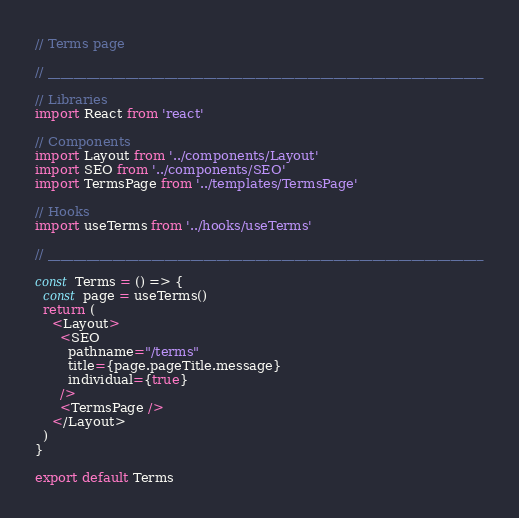<code> <loc_0><loc_0><loc_500><loc_500><_TypeScript_>// Terms page

// ___________________________________________________________________

// Libraries
import React from 'react'

// Components
import Layout from '../components/Layout'
import SEO from '../components/SEO'
import TermsPage from '../templates/TermsPage'

// Hooks
import useTerms from '../hooks/useTerms'

// ___________________________________________________________________

const Terms = () => {
  const page = useTerms()
  return (
    <Layout>
      <SEO
        pathname="/terms"
        title={page.pageTitle.message}
        individual={true}
      />
      <TermsPage />
    </Layout>
  )
}

export default Terms
</code> 